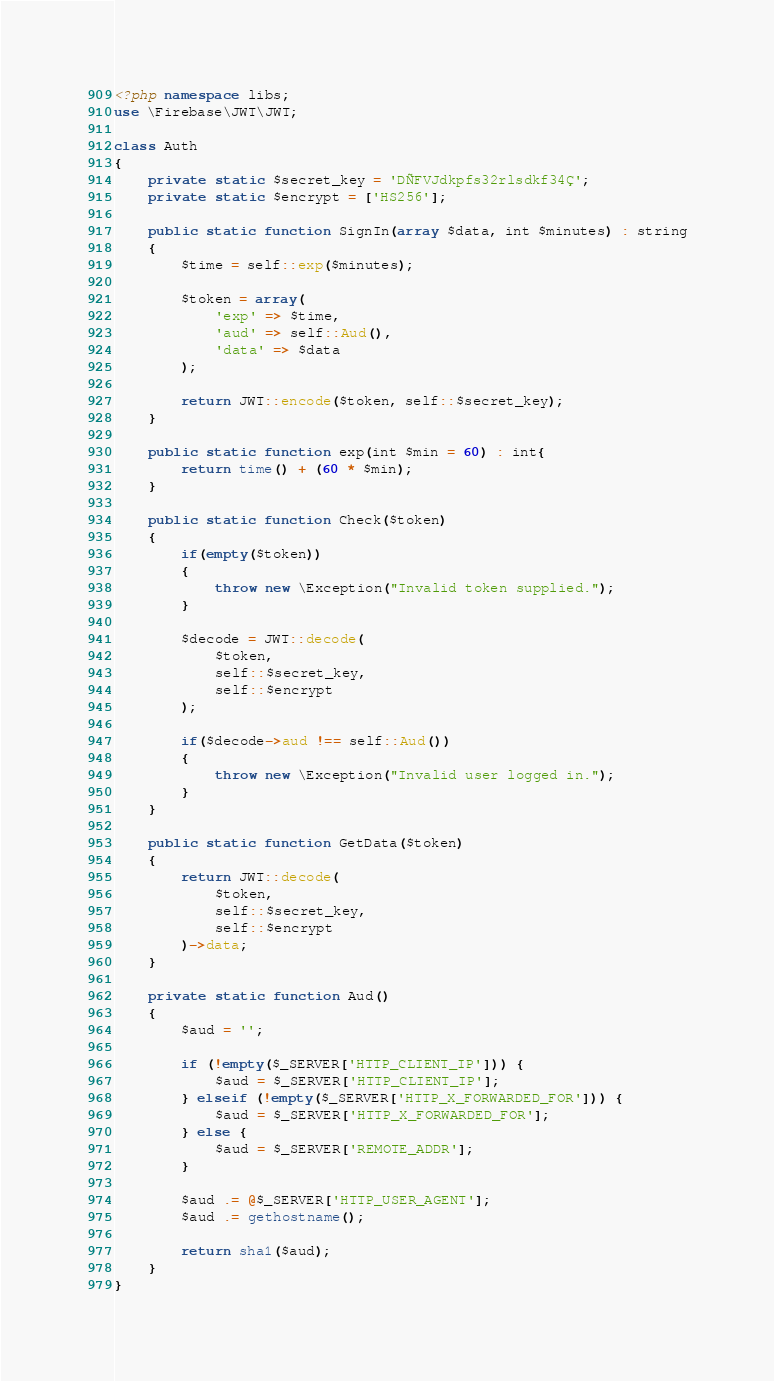<code> <loc_0><loc_0><loc_500><loc_500><_PHP_><?php namespace libs;
use \Firebase\JWT\JWT;

class Auth
{
    private static $secret_key = 'DÑFVJdkpfs32rlsdkf34Ç';
    private static $encrypt = ['HS256']; 

    public static function SignIn(array $data, int $minutes) : string
    {
        $time = self::exp($minutes);

        $token = array(
            'exp' => $time,
            'aud' => self::Aud(),
            'data' => $data
        );

        return JWT::encode($token, self::$secret_key);
    }

    public static function exp(int $min = 60) : int{
        return time() + (60 * $min); 
    }

    public static function Check($token)
    {
        if(empty($token))
        {
            throw new \Exception("Invalid token supplied.");
        }

        $decode = JWT::decode(
            $token,
            self::$secret_key,
            self::$encrypt
        );

        if($decode->aud !== self::Aud())
        {
            throw new \Exception("Invalid user logged in.");
        }
    }

    public static function GetData($token)
    {
        return JWT::decode(
            $token,
            self::$secret_key,
            self::$encrypt
        )->data;
    }

    private static function Aud()
    {
        $aud = '';

        if (!empty($_SERVER['HTTP_CLIENT_IP'])) {
            $aud = $_SERVER['HTTP_CLIENT_IP'];
        } elseif (!empty($_SERVER['HTTP_X_FORWARDED_FOR'])) {
            $aud = $_SERVER['HTTP_X_FORWARDED_FOR'];
        } else {
            $aud = $_SERVER['REMOTE_ADDR'];
        }

        $aud .= @$_SERVER['HTTP_USER_AGENT'];
        $aud .= gethostname();

        return sha1($aud);
    }
}</code> 